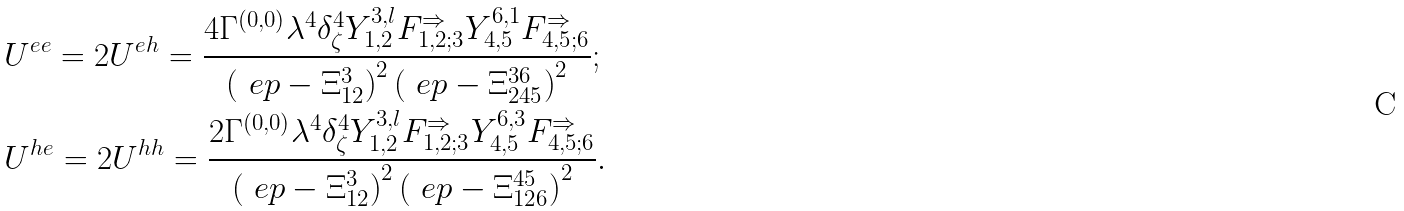<formula> <loc_0><loc_0><loc_500><loc_500>& U ^ { e e } = 2 U ^ { e h } = \frac { 4 \Gamma ^ { ( 0 , 0 ) } \lambda ^ { 4 } \delta _ { \zeta } ^ { 4 } Y _ { 1 , 2 } ^ { 3 , l } F _ { 1 , 2 ; 3 } ^ { \Rightarrow } Y _ { 4 , 5 } ^ { 6 , 1 } F _ { 4 , 5 ; 6 } ^ { \Rightarrow } } { \left ( \ e p - \Xi _ { 1 2 } ^ { 3 } \right ) ^ { 2 } \left ( \ e p - \Xi _ { 2 4 5 } ^ { 3 6 } \right ) ^ { 2 } } ; \\ & U ^ { h e } = 2 U ^ { h h } = \frac { 2 \Gamma ^ { ( 0 , 0 ) } \lambda ^ { 4 } \delta _ { \zeta } ^ { 4 } Y _ { 1 , 2 } ^ { 3 , l } F _ { 1 , 2 ; 3 } ^ { \Rightarrow } Y _ { 4 , 5 } ^ { 6 , 3 } F _ { 4 , 5 ; 6 } ^ { \Rightarrow } } { \left ( \ e p - \Xi _ { 1 2 } ^ { 3 } \right ) ^ { 2 } \left ( \ e p - \Xi ^ { 4 5 } _ { 1 2 6 } \right ) ^ { 2 } } .</formula> 